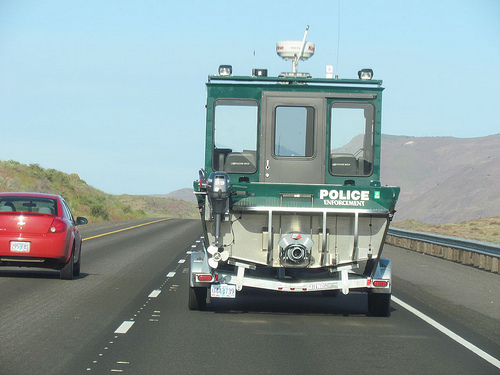<image>
Is there a car in front of the truck? No. The car is not in front of the truck. The spatial positioning shows a different relationship between these objects. Is the boat above the freeway? Yes. The boat is positioned above the freeway in the vertical space, higher up in the scene. 